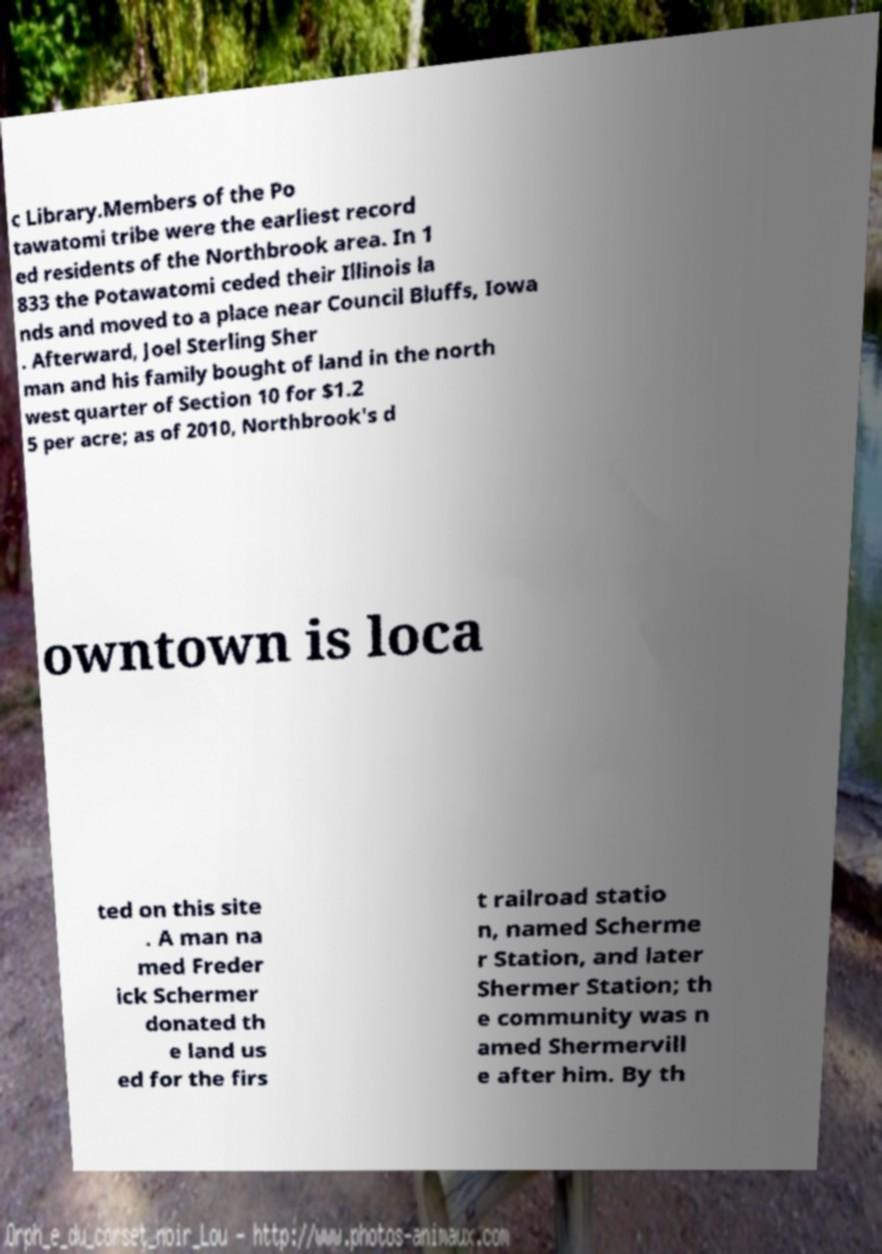Please identify and transcribe the text found in this image. c Library.Members of the Po tawatomi tribe were the earliest record ed residents of the Northbrook area. In 1 833 the Potawatomi ceded their Illinois la nds and moved to a place near Council Bluffs, Iowa . Afterward, Joel Sterling Sher man and his family bought of land in the north west quarter of Section 10 for $1.2 5 per acre; as of 2010, Northbrook's d owntown is loca ted on this site . A man na med Freder ick Schermer donated th e land us ed for the firs t railroad statio n, named Scherme r Station, and later Shermer Station; th e community was n amed Shermervill e after him. By th 